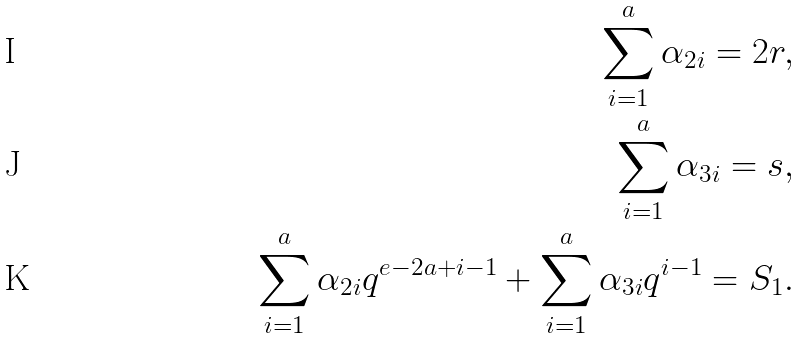Convert formula to latex. <formula><loc_0><loc_0><loc_500><loc_500>\sum _ { i = 1 } ^ { a } \alpha _ { 2 i } = 2 r , \\ \sum _ { i = 1 } ^ { a } \alpha _ { 3 i } = s , \\ \sum _ { i = 1 } ^ { a } \alpha _ { 2 i } q ^ { e - 2 a + i - 1 } + \sum _ { i = 1 } ^ { a } \alpha _ { 3 i } q ^ { i - 1 } = S _ { 1 } .</formula> 